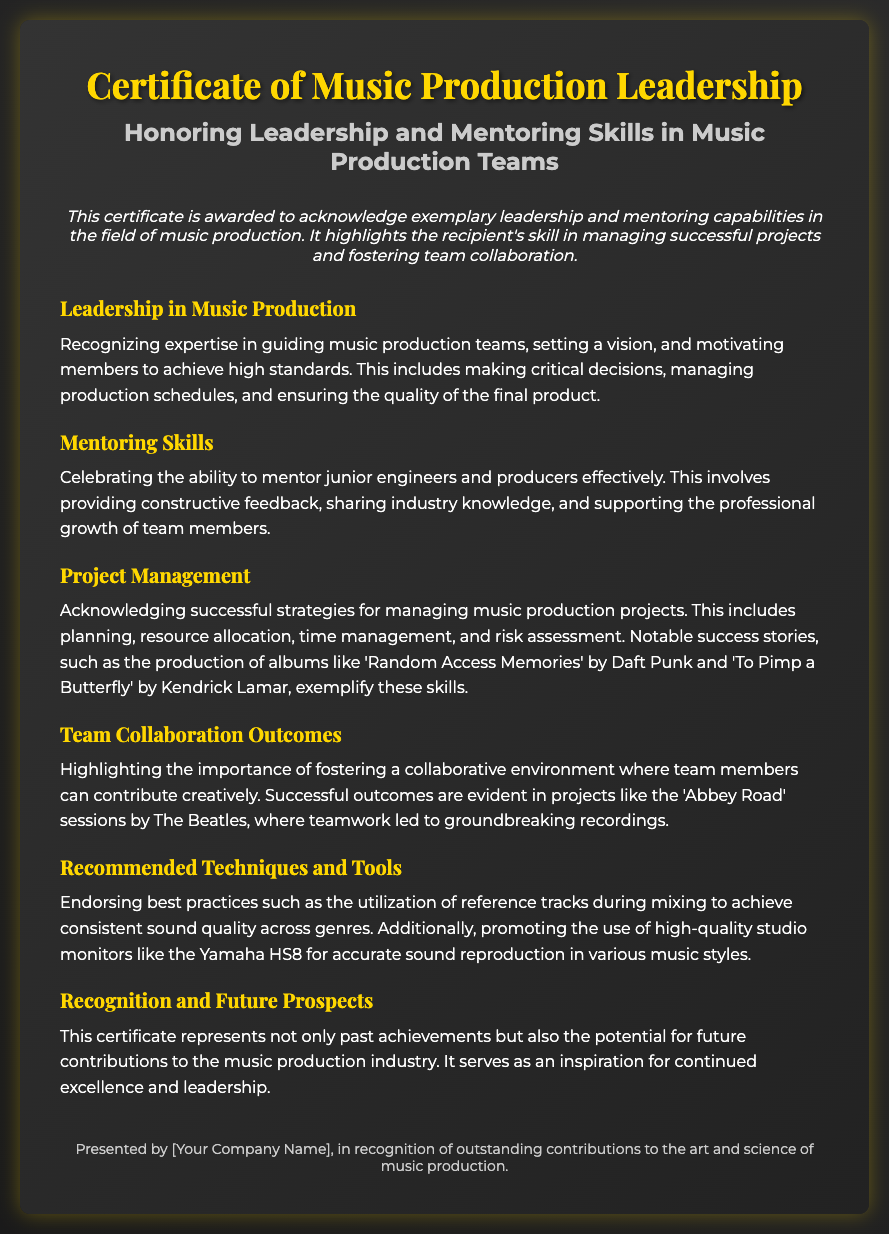What is the title of the certificate? The title of the certificate is prominently displayed at the top of the document as "Certificate of Music Production Leadership."
Answer: Certificate of Music Production Leadership What is recognized in the certificate? The document highlights leadership and mentoring skills in music production teams.
Answer: Leadership and mentoring skills Which project is mentioned as an example of successful project management? 'Random Access Memories' by Daft Punk is cited as a notable success story in project management.
Answer: Random Access Memories What is emphasized in the section about team collaboration outcomes? The section highlights the importance of fostering a collaborative environment among team members.
Answer: Collaborative environment What specific skills are celebrated under mentoring skills? The mentoring skills section emphasizes providing constructive feedback, sharing industry knowledge, and supporting professional growth.
Answer: Constructive feedback, sharing industry knowledge, supporting professional growth What technique is recommended for achieving consistent sound quality? Utilizing reference tracks during mixing is recommended for achieving consistent sound quality.
Answer: Reference tracks What color is used for the document's title text? The color of the title text is gold as specified in the styling of the certificate.
Answer: Gold How many sections are present in the document? There are a total of six sections outlined in the certificate.
Answer: Six sections 